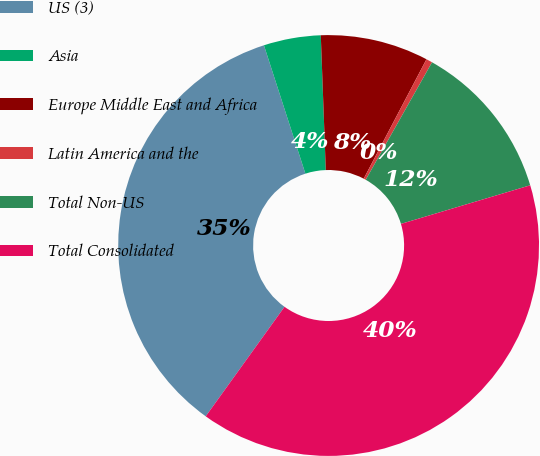Convert chart to OTSL. <chart><loc_0><loc_0><loc_500><loc_500><pie_chart><fcel>US (3)<fcel>Asia<fcel>Europe Middle East and Africa<fcel>Latin America and the<fcel>Total Non-US<fcel>Total Consolidated<nl><fcel>35.1%<fcel>4.38%<fcel>8.29%<fcel>0.48%<fcel>12.2%<fcel>39.54%<nl></chart> 